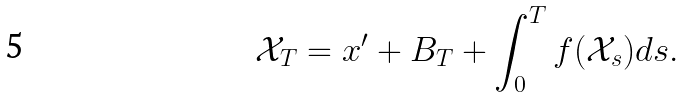<formula> <loc_0><loc_0><loc_500><loc_500>\mathcal { X } _ { T } = x ^ { \prime } + B _ { T } + \int _ { 0 } ^ { T } f ( \mathcal { X } _ { s } ) d s .</formula> 